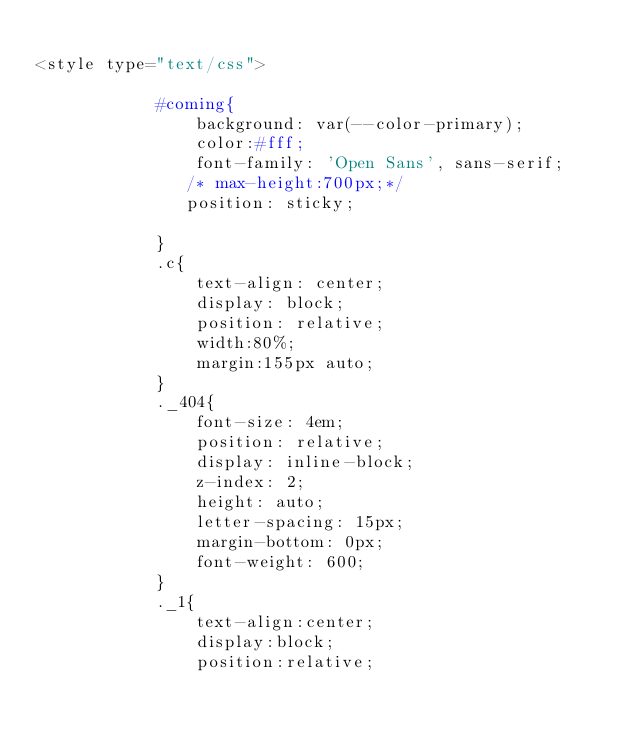<code> <loc_0><loc_0><loc_500><loc_500><_PHP_>
<style type="text/css">
    
            #coming{
                background: var(--color-primary);
                color:#fff;
                font-family: 'Open Sans', sans-serif;
               /* max-height:700px;*/
               position: sticky;
               
            }
            .c{
                text-align: center;
                display: block;
                position: relative;
                width:80%;
                margin:155px auto;
            }
            ._404{
                font-size: 4em;
                position: relative;
                display: inline-block;
                z-index: 2;
                height: auto;
                letter-spacing: 15px;
                margin-bottom: 0px;
                font-weight: 600;
            }
            ._1{
                text-align:center;
                display:block;
                position:relative;</code> 